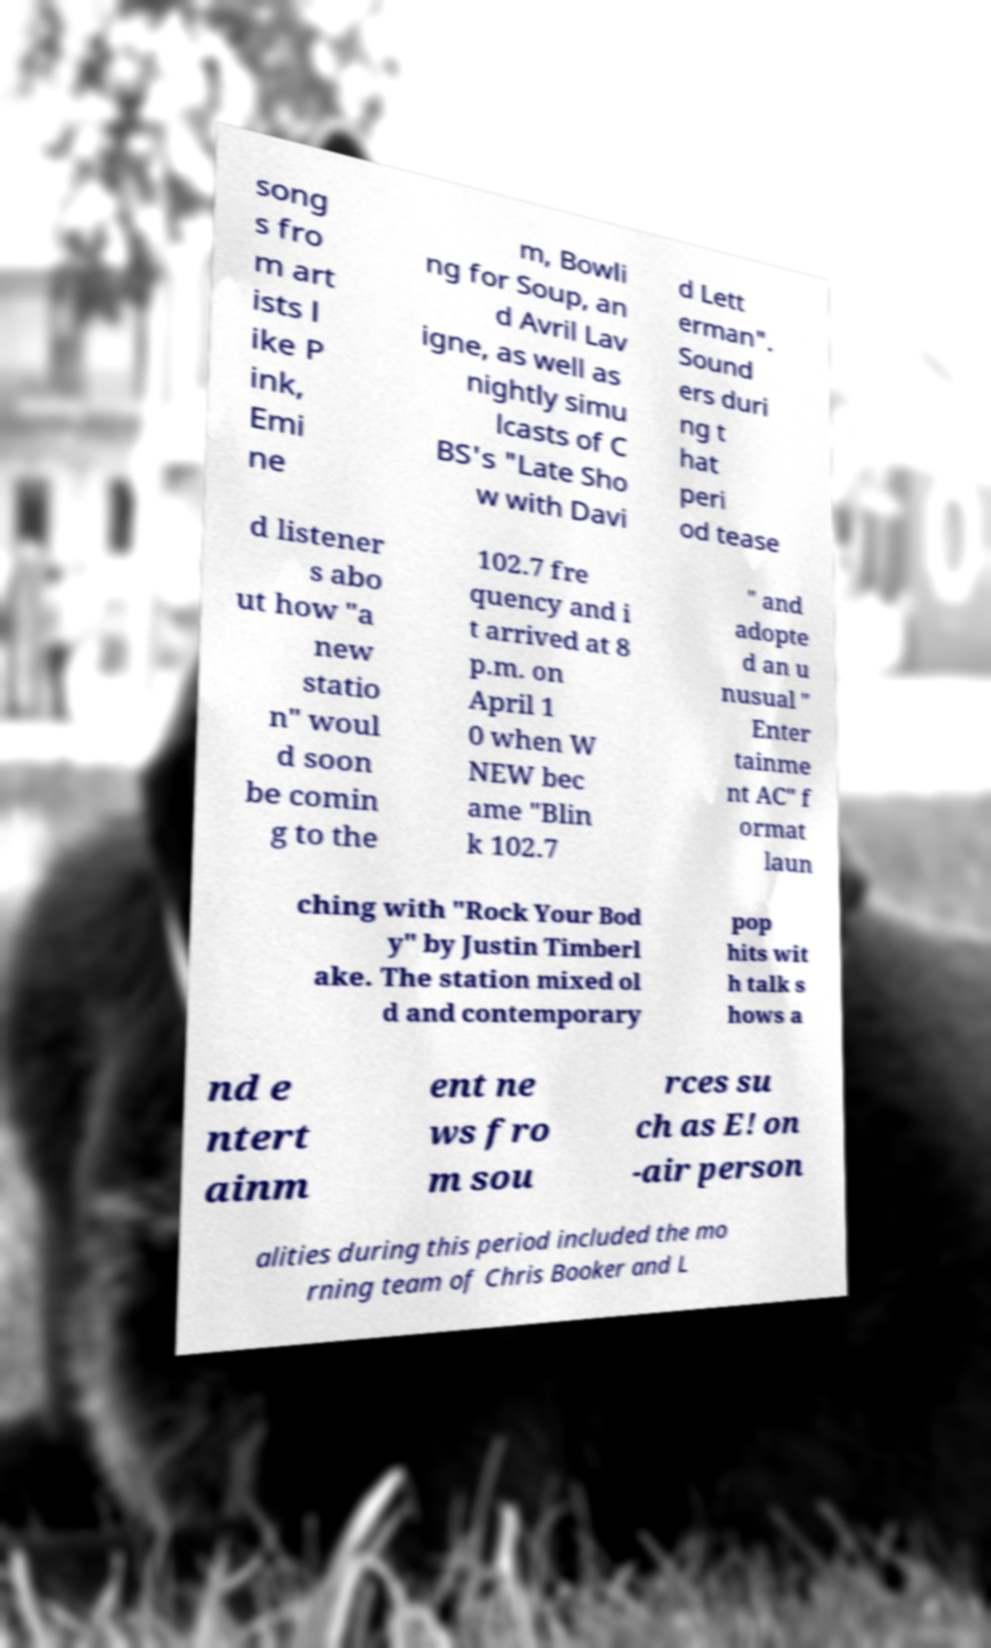Can you read and provide the text displayed in the image?This photo seems to have some interesting text. Can you extract and type it out for me? song s fro m art ists l ike P ink, Emi ne m, Bowli ng for Soup, an d Avril Lav igne, as well as nightly simu lcasts of C BS's "Late Sho w with Davi d Lett erman". Sound ers duri ng t hat peri od tease d listener s abo ut how "a new statio n" woul d soon be comin g to the 102.7 fre quency and i t arrived at 8 p.m. on April 1 0 when W NEW bec ame "Blin k 102.7 " and adopte d an u nusual " Enter tainme nt AC" f ormat laun ching with "Rock Your Bod y" by Justin Timberl ake. The station mixed ol d and contemporary pop hits wit h talk s hows a nd e ntert ainm ent ne ws fro m sou rces su ch as E! on -air person alities during this period included the mo rning team of Chris Booker and L 